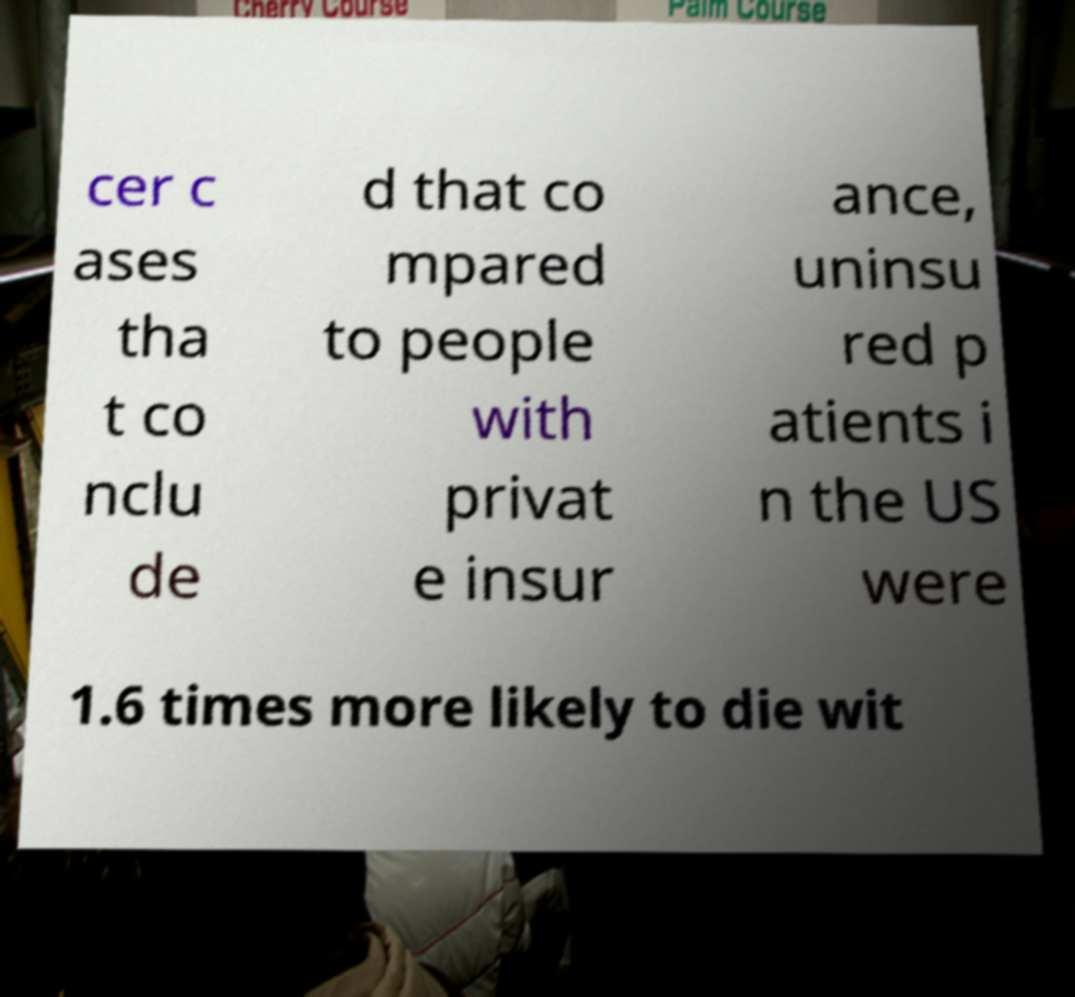Please identify and transcribe the text found in this image. cer c ases tha t co nclu de d that co mpared to people with privat e insur ance, uninsu red p atients i n the US were 1.6 times more likely to die wit 